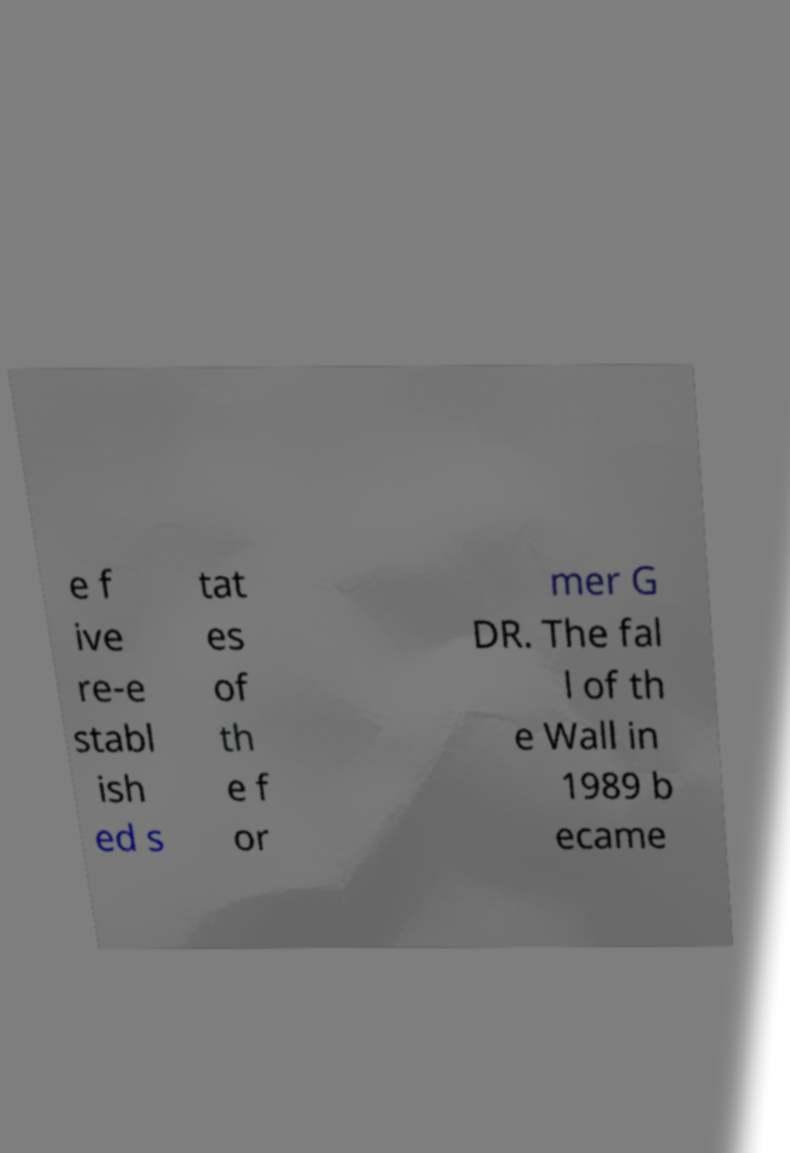What messages or text are displayed in this image? I need them in a readable, typed format. e f ive re-e stabl ish ed s tat es of th e f or mer G DR. The fal l of th e Wall in 1989 b ecame 